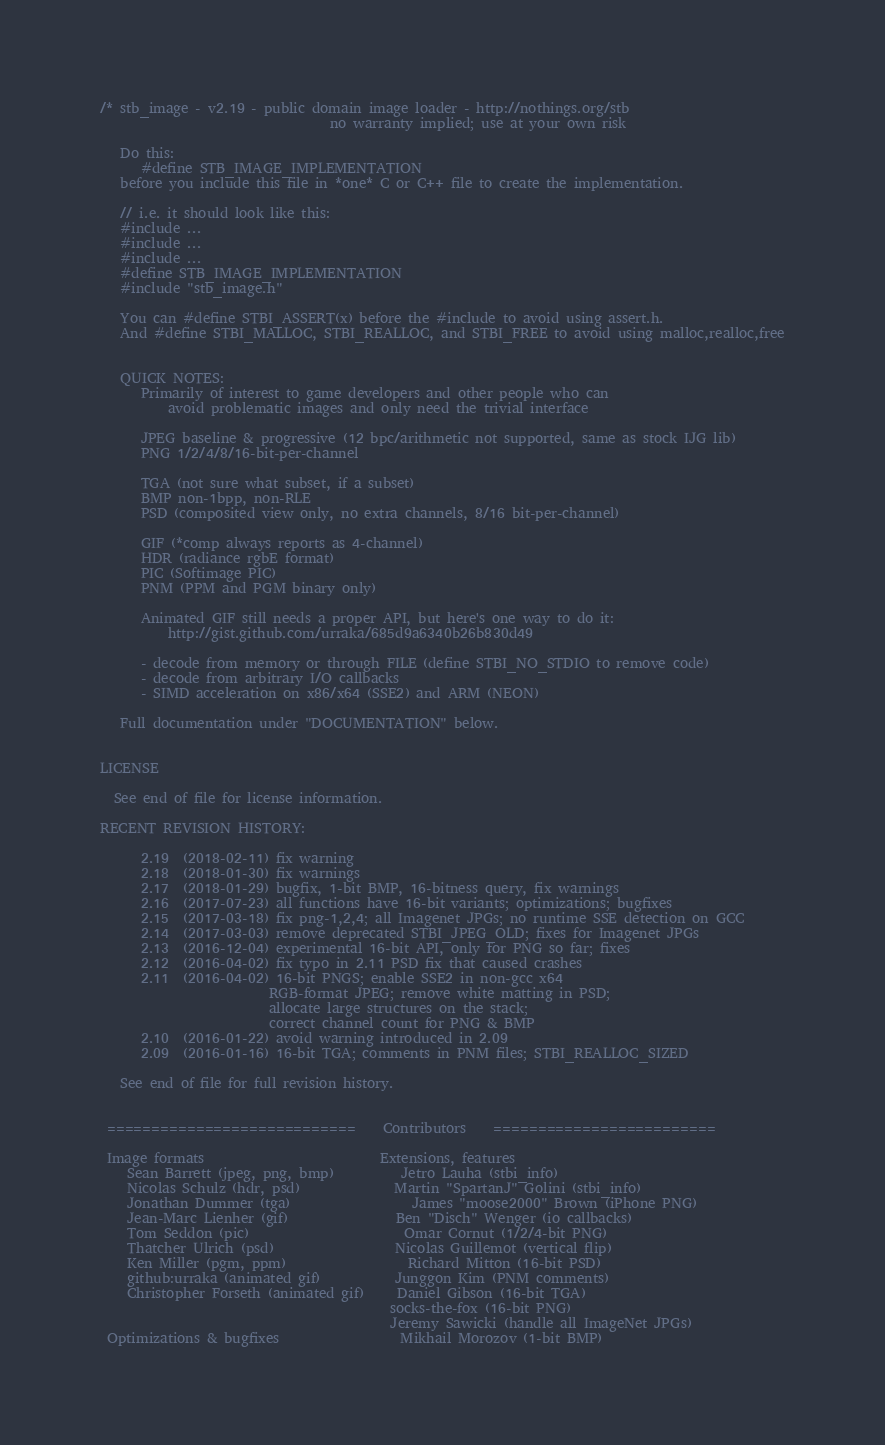<code> <loc_0><loc_0><loc_500><loc_500><_C_>/* stb_image - v2.19 - public domain image loader - http://nothings.org/stb
                                  no warranty implied; use at your own risk

   Do this:
      #define STB_IMAGE_IMPLEMENTATION
   before you include this file in *one* C or C++ file to create the implementation.

   // i.e. it should look like this:
   #include ...
   #include ...
   #include ...
   #define STB_IMAGE_IMPLEMENTATION
   #include "stb_image.h"

   You can #define STBI_ASSERT(x) before the #include to avoid using assert.h.
   And #define STBI_MALLOC, STBI_REALLOC, and STBI_FREE to avoid using malloc,realloc,free


   QUICK NOTES:
      Primarily of interest to game developers and other people who can
          avoid problematic images and only need the trivial interface

      JPEG baseline & progressive (12 bpc/arithmetic not supported, same as stock IJG lib)
      PNG 1/2/4/8/16-bit-per-channel

      TGA (not sure what subset, if a subset)
      BMP non-1bpp, non-RLE
      PSD (composited view only, no extra channels, 8/16 bit-per-channel)

      GIF (*comp always reports as 4-channel)
      HDR (radiance rgbE format)
      PIC (Softimage PIC)
      PNM (PPM and PGM binary only)

      Animated GIF still needs a proper API, but here's one way to do it:
          http://gist.github.com/urraka/685d9a6340b26b830d49

      - decode from memory or through FILE (define STBI_NO_STDIO to remove code)
      - decode from arbitrary I/O callbacks
      - SIMD acceleration on x86/x64 (SSE2) and ARM (NEON)

   Full documentation under "DOCUMENTATION" below.


LICENSE

  See end of file for license information.

RECENT REVISION HISTORY:

      2.19  (2018-02-11) fix warning
      2.18  (2018-01-30) fix warnings
      2.17  (2018-01-29) bugfix, 1-bit BMP, 16-bitness query, fix warnings
      2.16  (2017-07-23) all functions have 16-bit variants; optimizations; bugfixes
      2.15  (2017-03-18) fix png-1,2,4; all Imagenet JPGs; no runtime SSE detection on GCC
      2.14  (2017-03-03) remove deprecated STBI_JPEG_OLD; fixes for Imagenet JPGs
      2.13  (2016-12-04) experimental 16-bit API, only for PNG so far; fixes
      2.12  (2016-04-02) fix typo in 2.11 PSD fix that caused crashes
      2.11  (2016-04-02) 16-bit PNGS; enable SSE2 in non-gcc x64
                         RGB-format JPEG; remove white matting in PSD;
                         allocate large structures on the stack;
                         correct channel count for PNG & BMP
      2.10  (2016-01-22) avoid warning introduced in 2.09
      2.09  (2016-01-16) 16-bit TGA; comments in PNM files; STBI_REALLOC_SIZED

   See end of file for full revision history.


 ============================    Contributors    =========================

 Image formats                          Extensions, features
    Sean Barrett (jpeg, png, bmp)          Jetro Lauha (stbi_info)
    Nicolas Schulz (hdr, psd)              Martin "SpartanJ" Golini (stbi_info)
    Jonathan Dummer (tga)                  James "moose2000" Brown (iPhone PNG)
    Jean-Marc Lienher (gif)                Ben "Disch" Wenger (io callbacks)
    Tom Seddon (pic)                       Omar Cornut (1/2/4-bit PNG)
    Thatcher Ulrich (psd)                  Nicolas Guillemot (vertical flip)
    Ken Miller (pgm, ppm)                  Richard Mitton (16-bit PSD)
    github:urraka (animated gif)           Junggon Kim (PNM comments)
    Christopher Forseth (animated gif)     Daniel Gibson (16-bit TGA)
                                           socks-the-fox (16-bit PNG)
                                           Jeremy Sawicki (handle all ImageNet JPGs)
 Optimizations & bugfixes                  Mikhail Morozov (1-bit BMP)</code> 